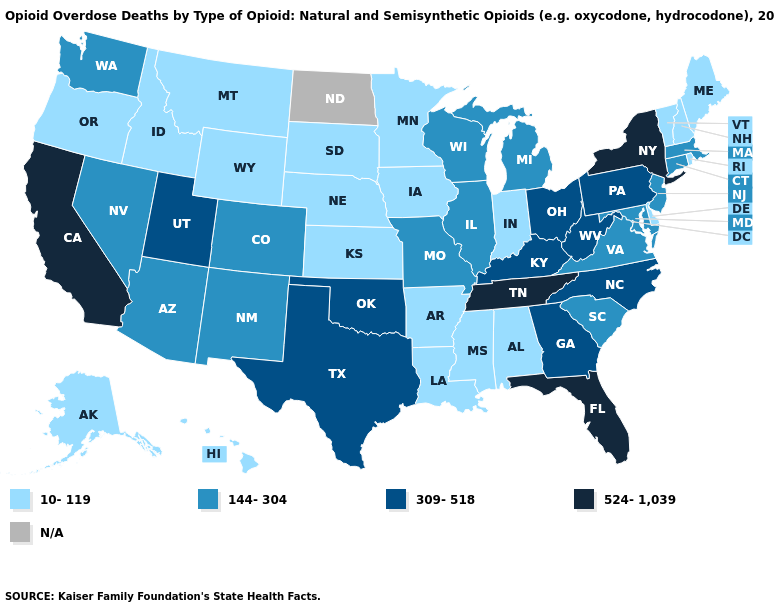What is the value of Kansas?
Short answer required. 10-119. What is the highest value in the MidWest ?
Concise answer only. 309-518. What is the value of New Jersey?
Concise answer only. 144-304. What is the value of Illinois?
Keep it brief. 144-304. What is the value of Delaware?
Keep it brief. 10-119. Which states have the lowest value in the USA?
Answer briefly. Alabama, Alaska, Arkansas, Delaware, Hawaii, Idaho, Indiana, Iowa, Kansas, Louisiana, Maine, Minnesota, Mississippi, Montana, Nebraska, New Hampshire, Oregon, Rhode Island, South Dakota, Vermont, Wyoming. Does New York have the lowest value in the Northeast?
Concise answer only. No. Does Maryland have the lowest value in the South?
Concise answer only. No. Name the states that have a value in the range 309-518?
Concise answer only. Georgia, Kentucky, North Carolina, Ohio, Oklahoma, Pennsylvania, Texas, Utah, West Virginia. Name the states that have a value in the range N/A?
Concise answer only. North Dakota. Among the states that border Michigan , does Wisconsin have the lowest value?
Concise answer only. No. What is the value of Illinois?
Answer briefly. 144-304. Name the states that have a value in the range N/A?
Concise answer only. North Dakota. What is the lowest value in the USA?
Concise answer only. 10-119. 